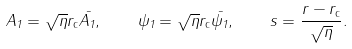<formula> <loc_0><loc_0><loc_500><loc_500>A _ { 1 } = \sqrt { \eta } r _ { \mathrm c } \bar { A _ { 1 } } , \quad \psi _ { 1 } = \sqrt { \eta } r _ { \mathrm c } \bar { \psi _ { 1 } } , \quad s = \frac { r - r _ { \mathrm c } } { \sqrt { \eta } } .</formula> 